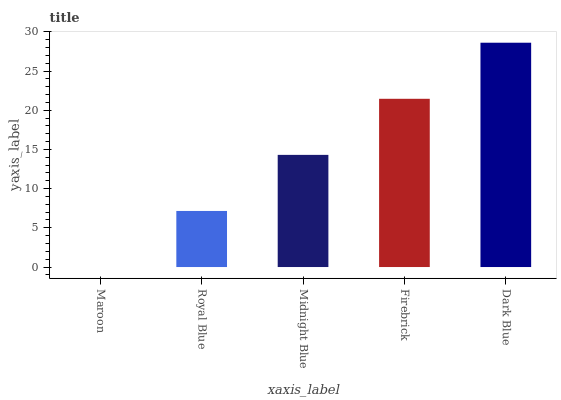Is Maroon the minimum?
Answer yes or no. Yes. Is Dark Blue the maximum?
Answer yes or no. Yes. Is Royal Blue the minimum?
Answer yes or no. No. Is Royal Blue the maximum?
Answer yes or no. No. Is Royal Blue greater than Maroon?
Answer yes or no. Yes. Is Maroon less than Royal Blue?
Answer yes or no. Yes. Is Maroon greater than Royal Blue?
Answer yes or no. No. Is Royal Blue less than Maroon?
Answer yes or no. No. Is Midnight Blue the high median?
Answer yes or no. Yes. Is Midnight Blue the low median?
Answer yes or no. Yes. Is Royal Blue the high median?
Answer yes or no. No. Is Maroon the low median?
Answer yes or no. No. 